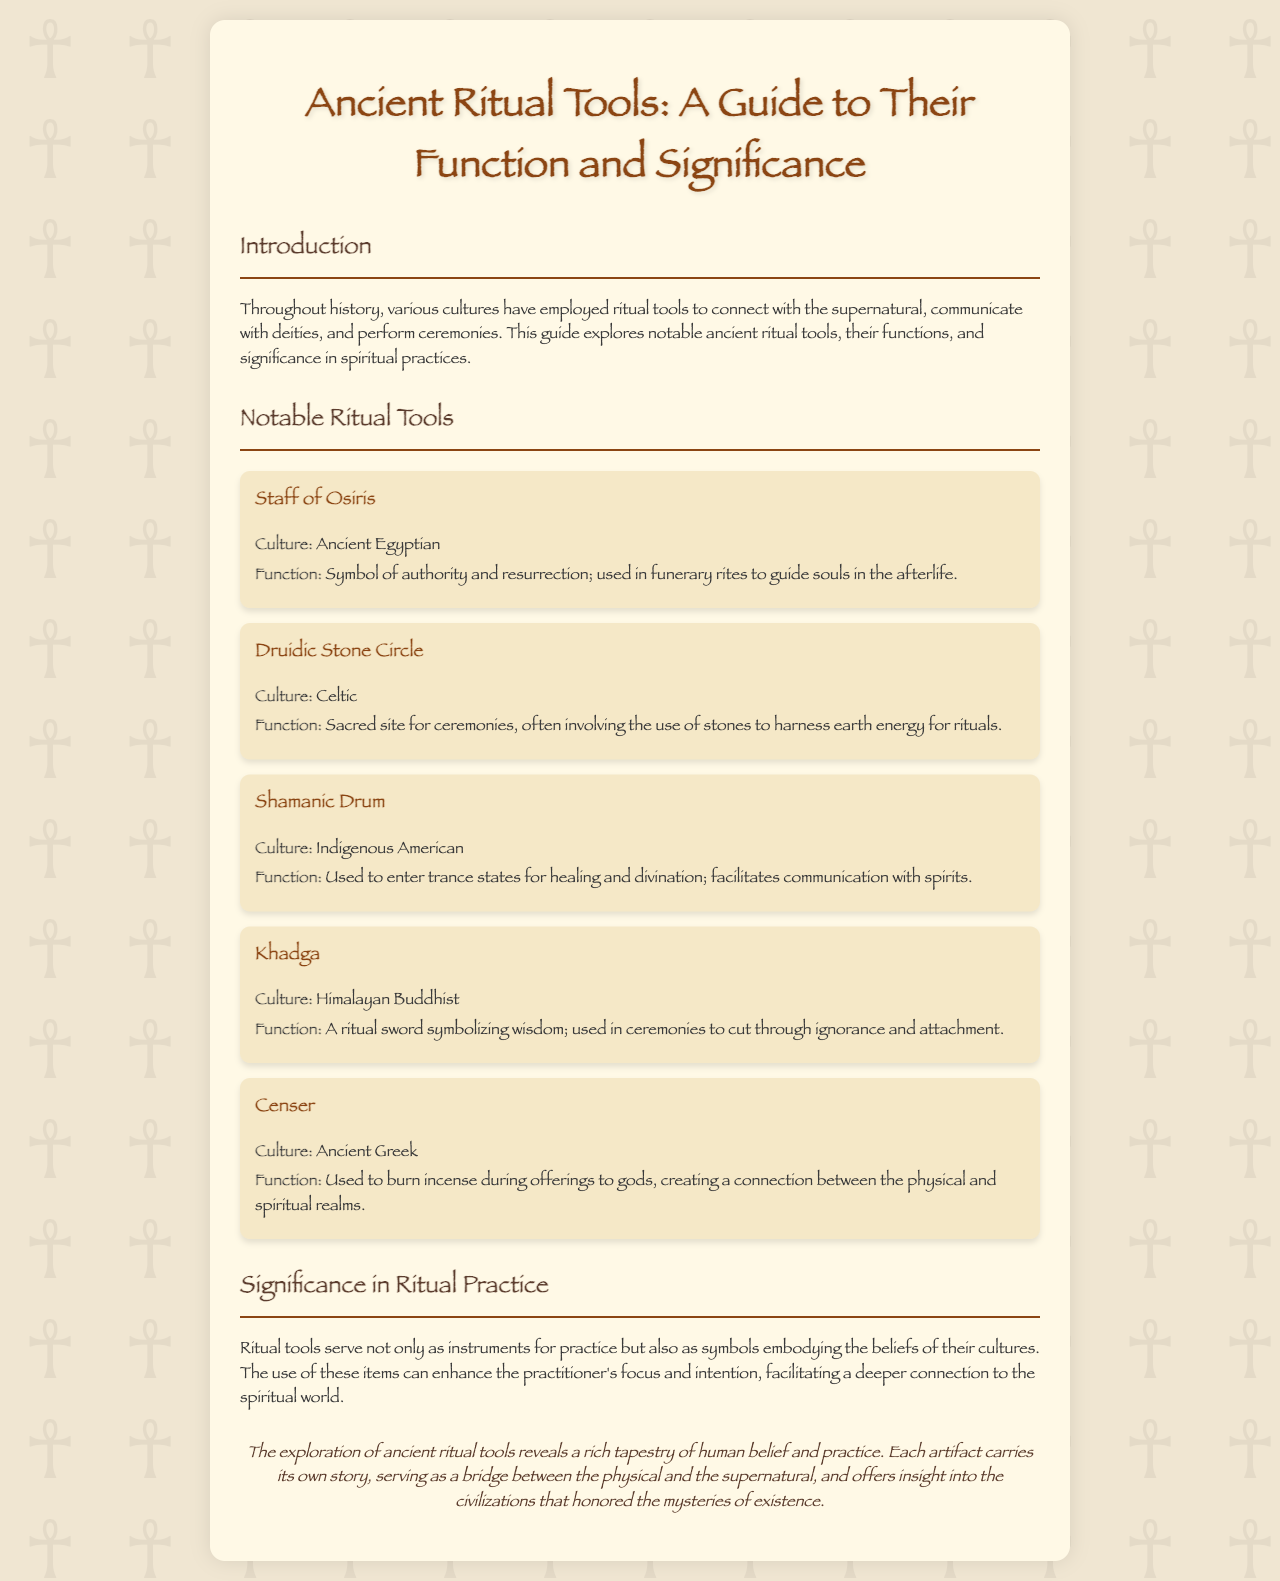What is the title of the brochure? The title is stated prominently at the top of the document.
Answer: Ancient Ritual Tools: A Guide to Their Function and Significance Which culture does the Staff of Osiris belong to? The culture is mentioned directly under the title of the tool within the document.
Answer: Ancient Egyptian What is the function of the Druidic Stone Circle? The function is clearly defined in the description of the tool.
Answer: Sacred site for ceremonies How is the Shamanic Drum used in rituals? The use is detailed in the second part of the tool's description.
Answer: To enter trance states Which ritual tool symbolizes wisdom? The tool that embodies this symbolism is specified in the document.
Answer: Khadga What is a common use of the Censer in Ancient Greek practices? The common use is described in the context of offerings to gods.
Answer: Burn incense What do ritual tools enhance according to the document? The specific aspect that ritual tools enhance is outlined in the significance section.
Answer: Focus and intention What does the conclusion suggest about ancient ritual tools? The conclusion conveys a particular sentiment regarding the implications of these artifacts.
Answer: Bridge between the physical and the supernatural 